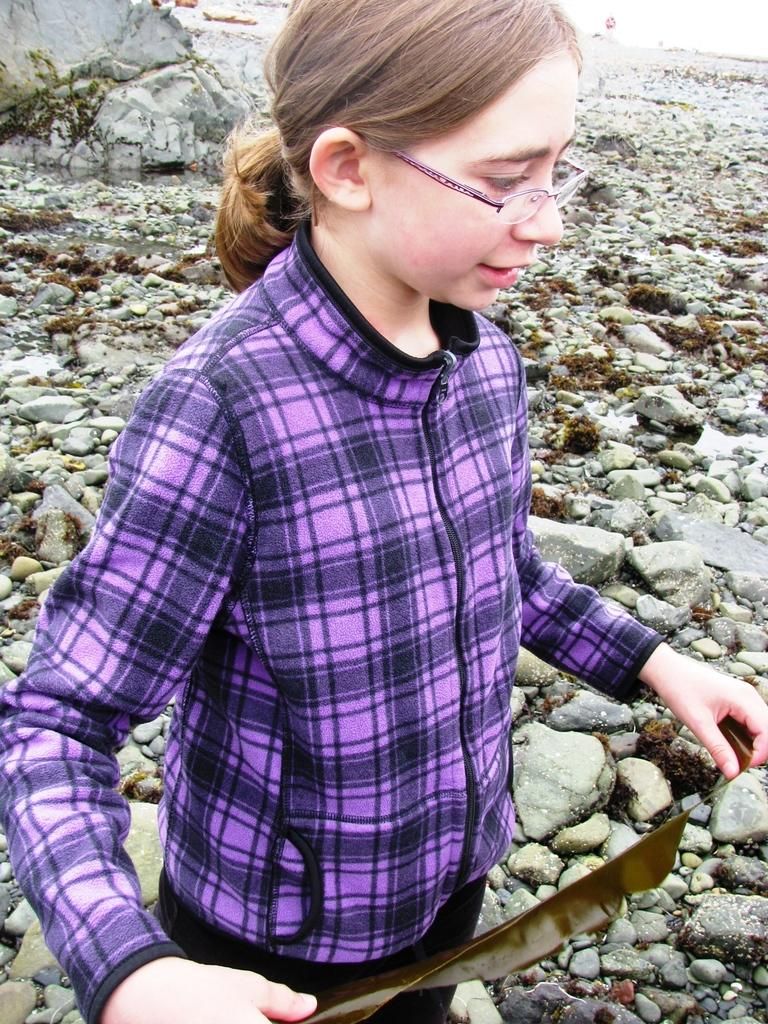Who is present in the image? There is a woman in the image. What is the woman doing in the image? The woman is standing on a surface. What can be seen on the surface where the woman is standing? There are stones on the surface. What is the tendency of the flock of birds in the image? There are no birds present in the image, so it is not possible to determine the tendency of any flock. 